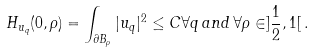<formula> <loc_0><loc_0><loc_500><loc_500>H _ { u _ { q } } ( 0 , \rho ) = \int _ { \partial B _ { \rho } } | u _ { q } | ^ { 2 } \leq C \forall q \, a n d \, \forall \rho \in ] \frac { 1 } { 2 } , 1 [ \, .</formula> 